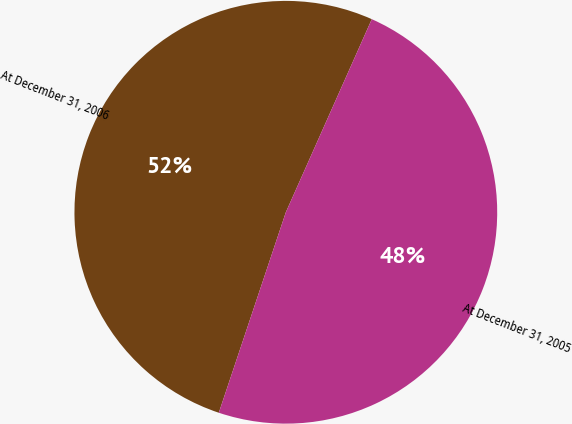<chart> <loc_0><loc_0><loc_500><loc_500><pie_chart><fcel>At December 31, 2006<fcel>At December 31, 2005<nl><fcel>51.53%<fcel>48.47%<nl></chart> 